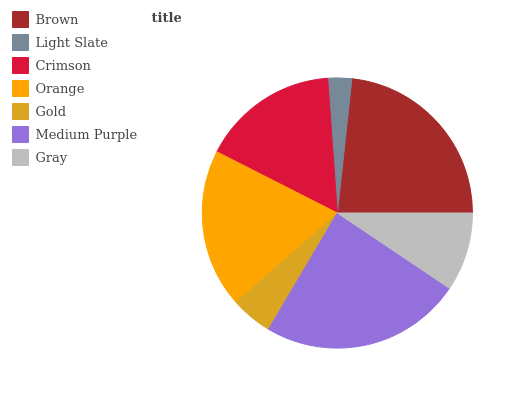Is Light Slate the minimum?
Answer yes or no. Yes. Is Medium Purple the maximum?
Answer yes or no. Yes. Is Crimson the minimum?
Answer yes or no. No. Is Crimson the maximum?
Answer yes or no. No. Is Crimson greater than Light Slate?
Answer yes or no. Yes. Is Light Slate less than Crimson?
Answer yes or no. Yes. Is Light Slate greater than Crimson?
Answer yes or no. No. Is Crimson less than Light Slate?
Answer yes or no. No. Is Crimson the high median?
Answer yes or no. Yes. Is Crimson the low median?
Answer yes or no. Yes. Is Gray the high median?
Answer yes or no. No. Is Orange the low median?
Answer yes or no. No. 